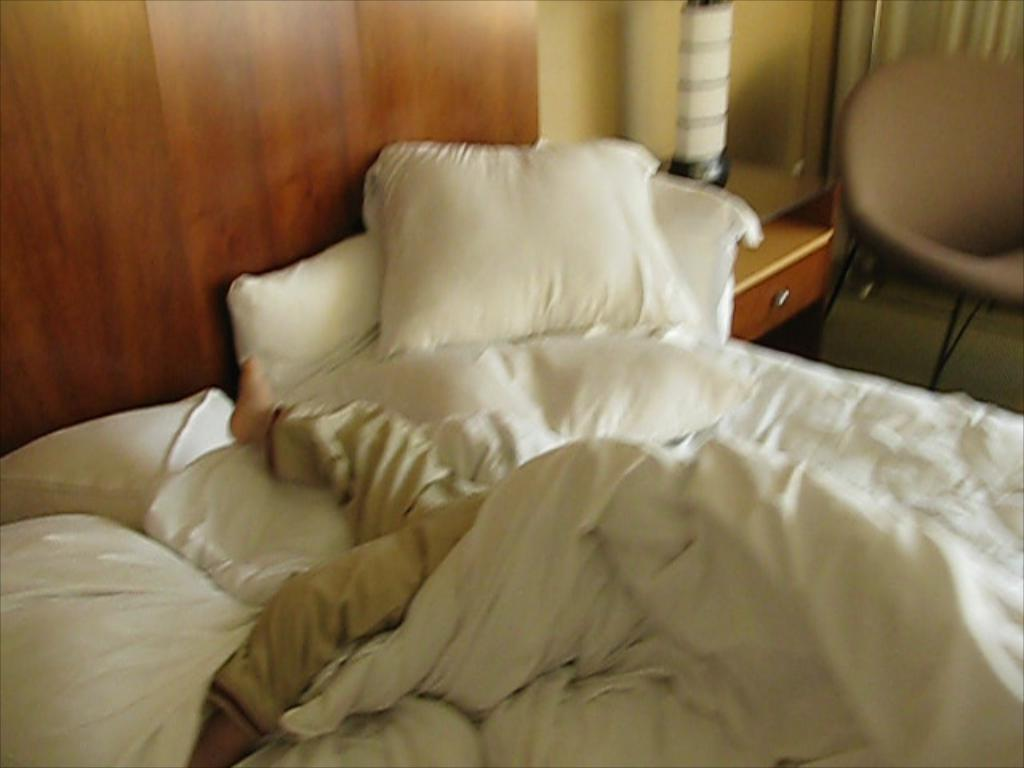What is the person in the image doing? The person is sleeping in the image. Where is the person sleeping? The person is on a bed. What is present on the bed besides the person? There are pillows on the bed. What furniture can be seen in the background of the image? There is a couch and a desk in the background of the image. What type of wall is visible in the background of the image? There is a wooden wall in the background of the image. What type of rabbit is sitting on the queen's lap in the image? There is no rabbit or queen present in the image; it features a person sleeping on a bed. 